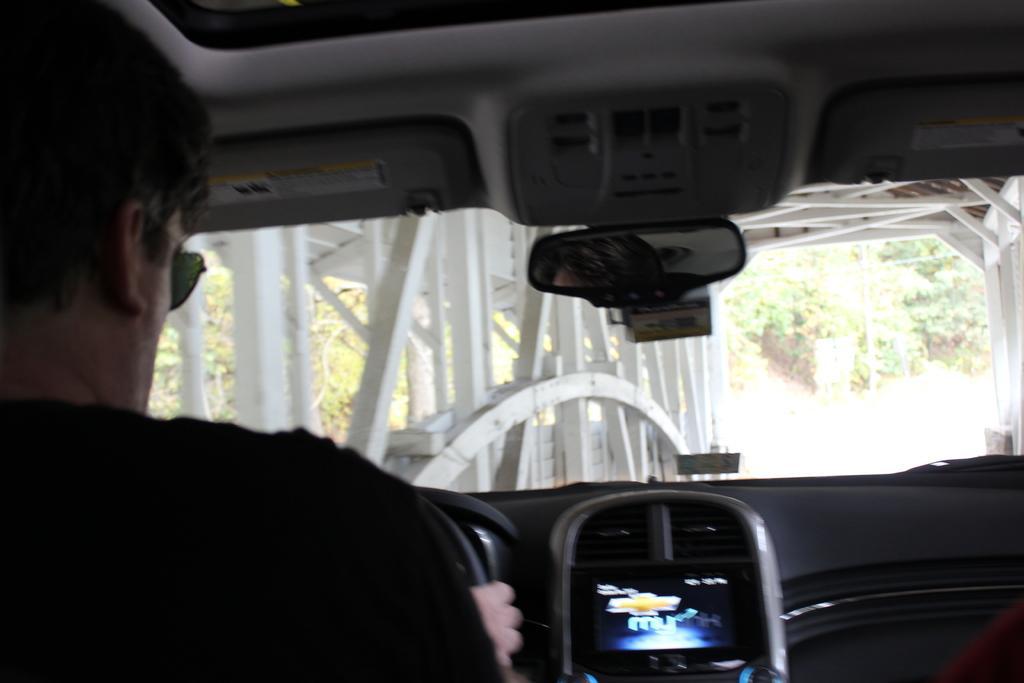Please provide a concise description of this image. In this picture there is a man who is wearing goggles and black t-shirt. He is sitting inside the car. Here we can see rear mirror. In the back we can see plants and trees. Here we can see steel fencing. 